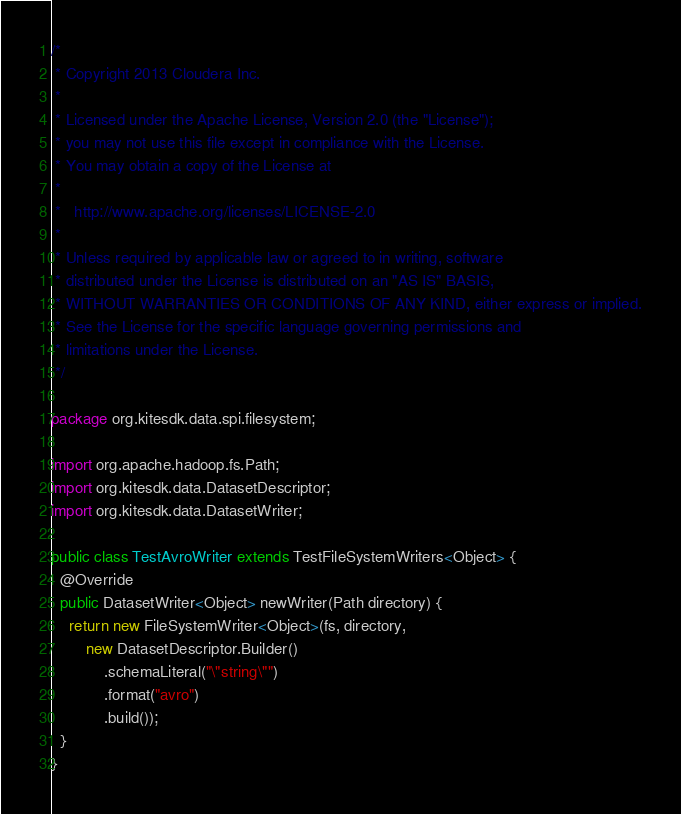Convert code to text. <code><loc_0><loc_0><loc_500><loc_500><_Java_>/*
 * Copyright 2013 Cloudera Inc.
 *
 * Licensed under the Apache License, Version 2.0 (the "License");
 * you may not use this file except in compliance with the License.
 * You may obtain a copy of the License at
 *
 *   http://www.apache.org/licenses/LICENSE-2.0
 *
 * Unless required by applicable law or agreed to in writing, software
 * distributed under the License is distributed on an "AS IS" BASIS,
 * WITHOUT WARRANTIES OR CONDITIONS OF ANY KIND, either express or implied.
 * See the License for the specific language governing permissions and
 * limitations under the License.
 */

package org.kitesdk.data.spi.filesystem;

import org.apache.hadoop.fs.Path;
import org.kitesdk.data.DatasetDescriptor;
import org.kitesdk.data.DatasetWriter;

public class TestAvroWriter extends TestFileSystemWriters<Object> {
  @Override
  public DatasetWriter<Object> newWriter(Path directory) {
    return new FileSystemWriter<Object>(fs, directory,
        new DatasetDescriptor.Builder()
            .schemaLiteral("\"string\"")
            .format("avro")
            .build());
  }
}
</code> 